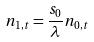Convert formula to latex. <formula><loc_0><loc_0><loc_500><loc_500>n _ { 1 , t } = \frac { s _ { 0 } } { \lambda } n _ { 0 , t }</formula> 